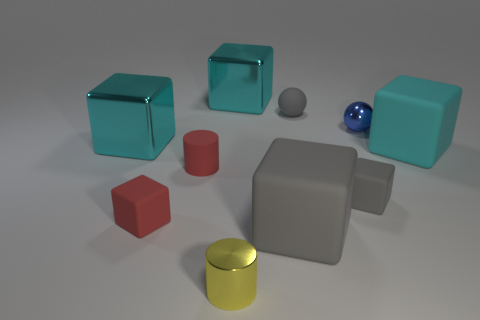Subtract all shiny cubes. How many cubes are left? 4 Subtract all cyan cubes. How many cubes are left? 3 Subtract 1 cylinders. How many cylinders are left? 1 Subtract all tiny yellow metal objects. Subtract all small gray rubber balls. How many objects are left? 8 Add 6 tiny yellow things. How many tiny yellow things are left? 7 Add 1 purple spheres. How many purple spheres exist? 1 Subtract 0 yellow balls. How many objects are left? 10 Subtract all cubes. How many objects are left? 4 Subtract all green balls. Subtract all brown blocks. How many balls are left? 2 Subtract all blue cylinders. How many cyan balls are left? 0 